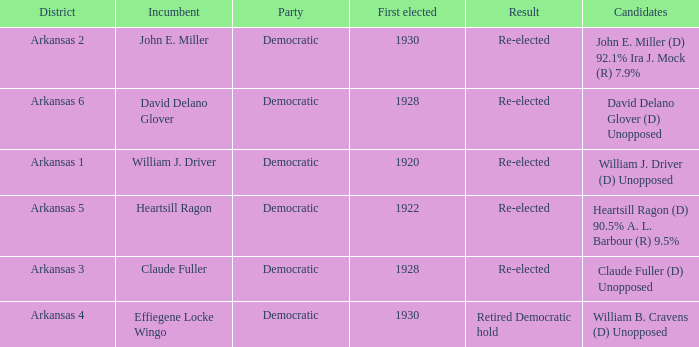Who competed in the election with incumbent claude fuller? Claude Fuller (D) Unopposed. 